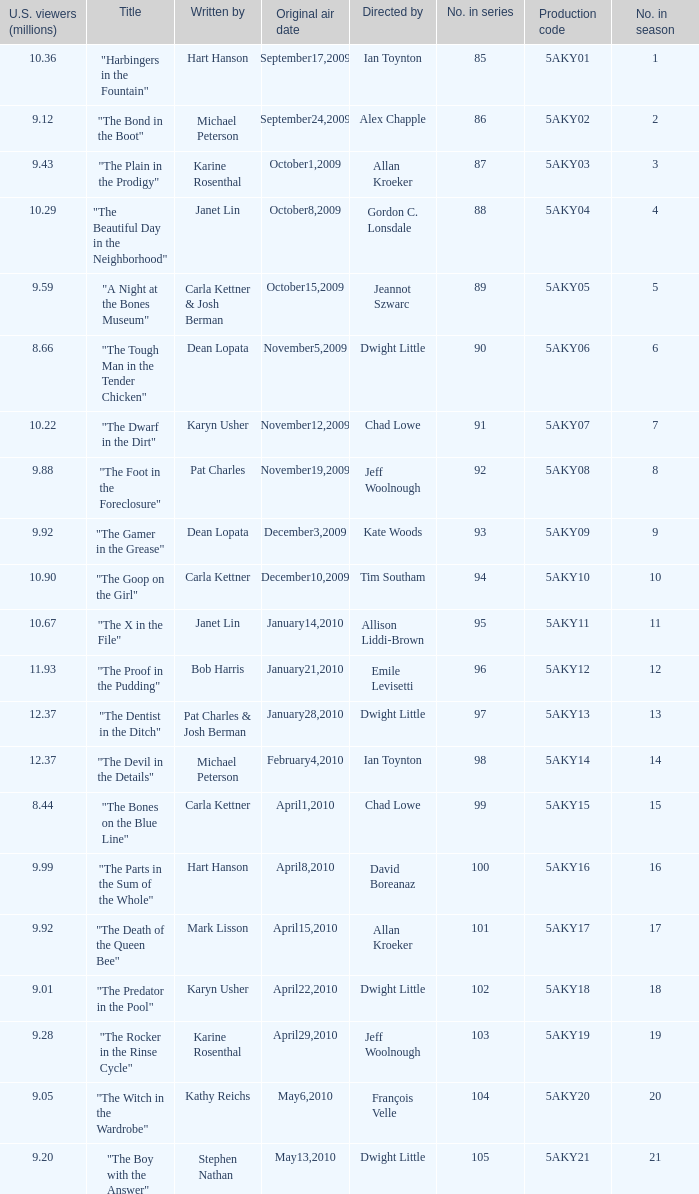Who was the writer of the episode with a production code of 5aky04? Janet Lin. 